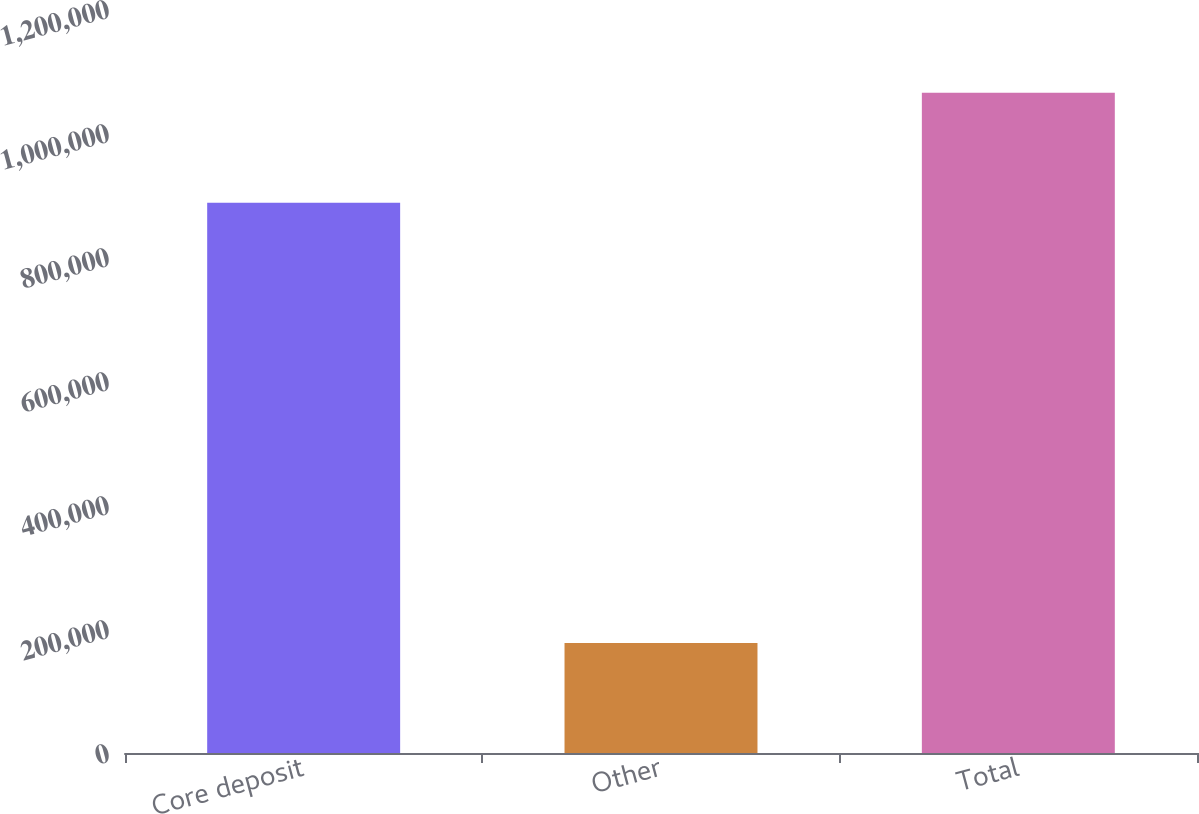Convert chart. <chart><loc_0><loc_0><loc_500><loc_500><bar_chart><fcel>Core deposit<fcel>Other<fcel>Total<nl><fcel>887459<fcel>177268<fcel>1.06473e+06<nl></chart> 